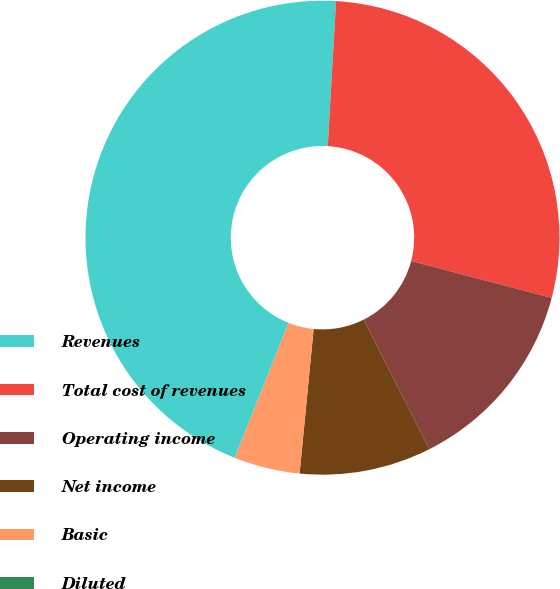<chart> <loc_0><loc_0><loc_500><loc_500><pie_chart><fcel>Revenues<fcel>Total cost of revenues<fcel>Operating income<fcel>Net income<fcel>Basic<fcel>Diluted<nl><fcel>44.89%<fcel>28.18%<fcel>13.47%<fcel>8.98%<fcel>4.49%<fcel>0.0%<nl></chart> 